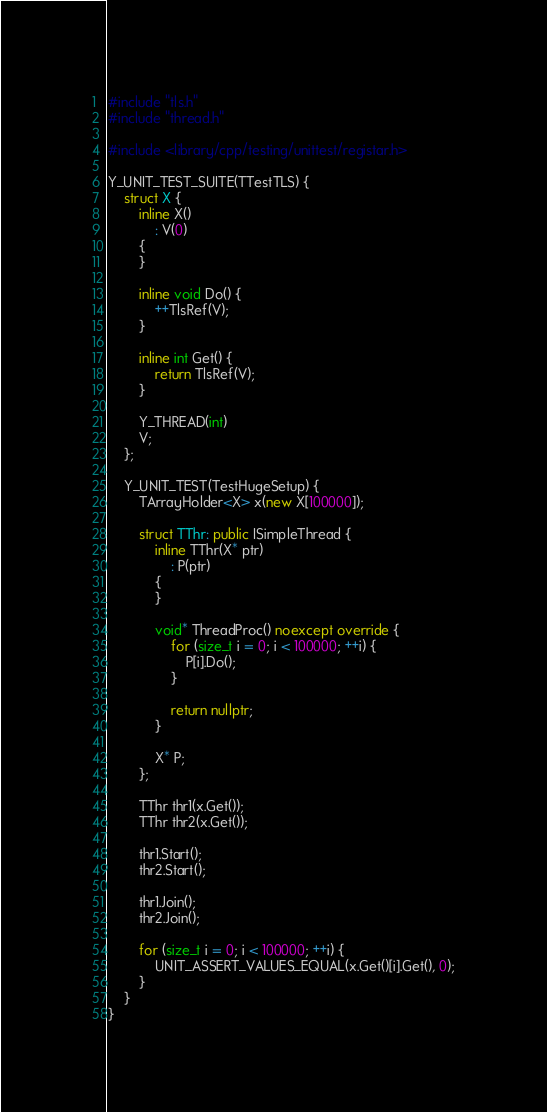Convert code to text. <code><loc_0><loc_0><loc_500><loc_500><_C++_>#include "tls.h"
#include "thread.h"

#include <library/cpp/testing/unittest/registar.h>

Y_UNIT_TEST_SUITE(TTestTLS) {
    struct X {
        inline X()
            : V(0)
        {
        }

        inline void Do() {
            ++TlsRef(V);
        }

        inline int Get() {
            return TlsRef(V);
        }

        Y_THREAD(int)
        V;
    };

    Y_UNIT_TEST(TestHugeSetup) {
        TArrayHolder<X> x(new X[100000]);

        struct TThr: public ISimpleThread {
            inline TThr(X* ptr)
                : P(ptr)
            {
            }

            void* ThreadProc() noexcept override {
                for (size_t i = 0; i < 100000; ++i) {
                    P[i].Do();
                }

                return nullptr;
            }

            X* P;
        };

        TThr thr1(x.Get());
        TThr thr2(x.Get());

        thr1.Start();
        thr2.Start();

        thr1.Join();
        thr2.Join();

        for (size_t i = 0; i < 100000; ++i) {
            UNIT_ASSERT_VALUES_EQUAL(x.Get()[i].Get(), 0);
        }
    }
}
</code> 